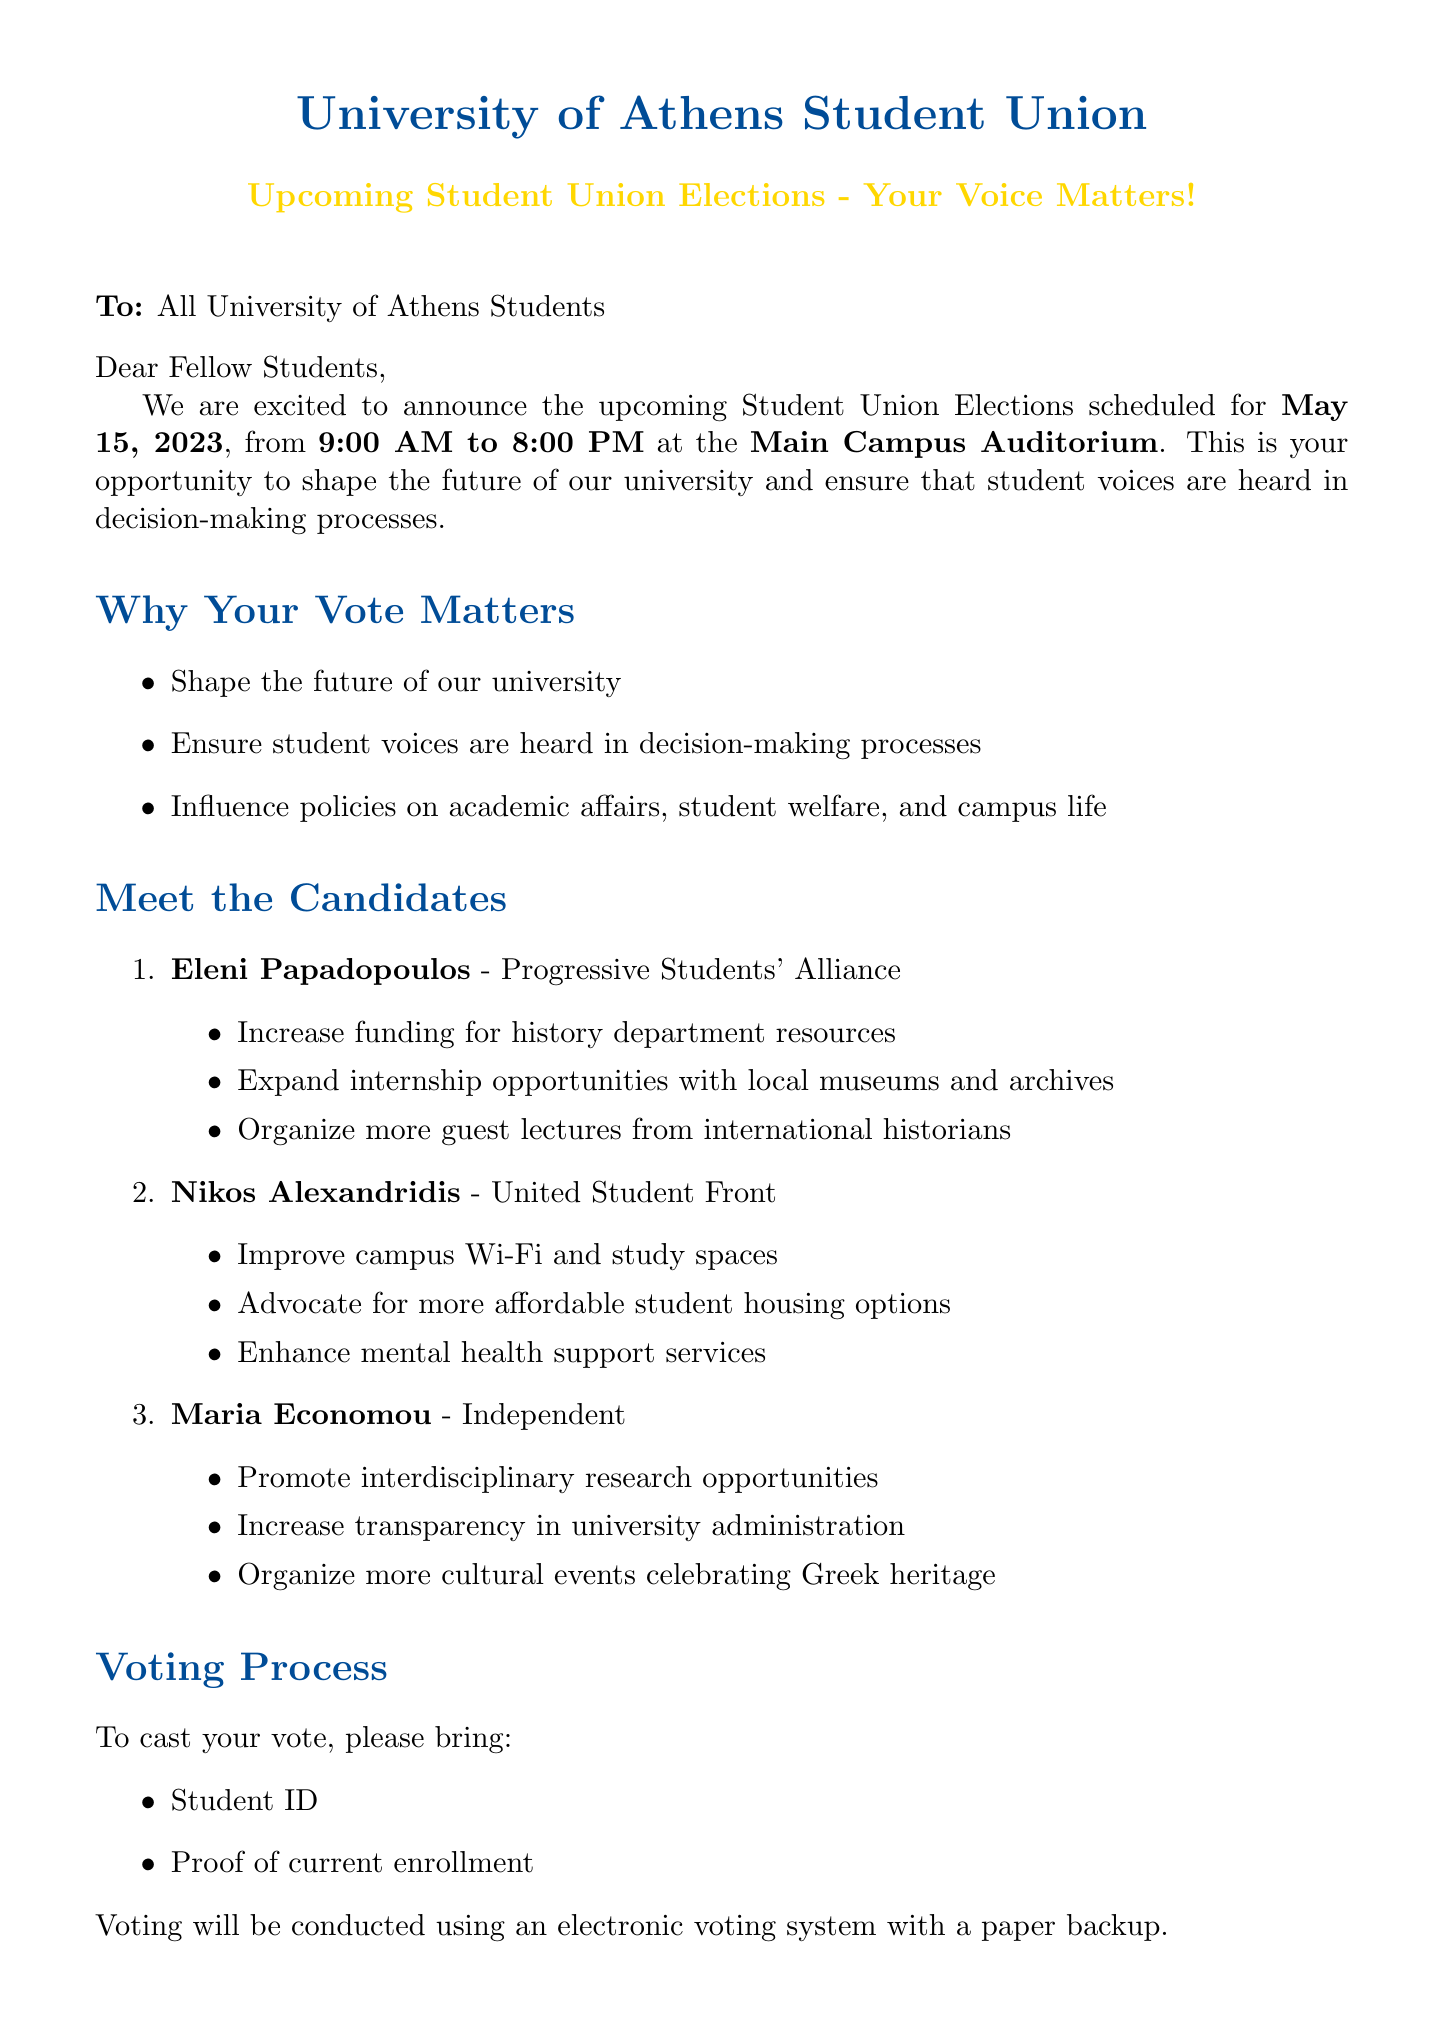What is the election date? The election date is specifically mentioned in the introduction section of the document.
Answer: May 15, 2023 Where will the voting take place? The location for voting is indicated in the introduction section of the document.
Answer: Main Campus Auditorium Who is representing the Progressive Students' Alliance? The document lists candidates and their respective parties in the "Meet the Candidates" section.
Answer: Eleni Papadopoulos What time do the polls close? The closing time for the polls is mentioned in the introduction section of the document.
Answer: 8:00 PM What is a key platform of Nikos Alexandridis? The document specifies key platforms for each candidate under their respective sections.
Answer: Improve campus Wi-Fi and study spaces When is the candidate debate scheduled? The document provides details about the candidate debate's date and time in the additional information section.
Answer: May 10, 2023 What document is required for voting? The requirements for voting are listed in the voting process section.
Answer: Student ID Which party is Maria Economou affiliated with? The affiliation of each candidate is clearly indicated in the "Meet the Candidates" section.
Answer: Independent How can students get involved in the election? The document includes a section on getting involved, detailing various ways to participate.
Answer: Volunteer as an election officer 